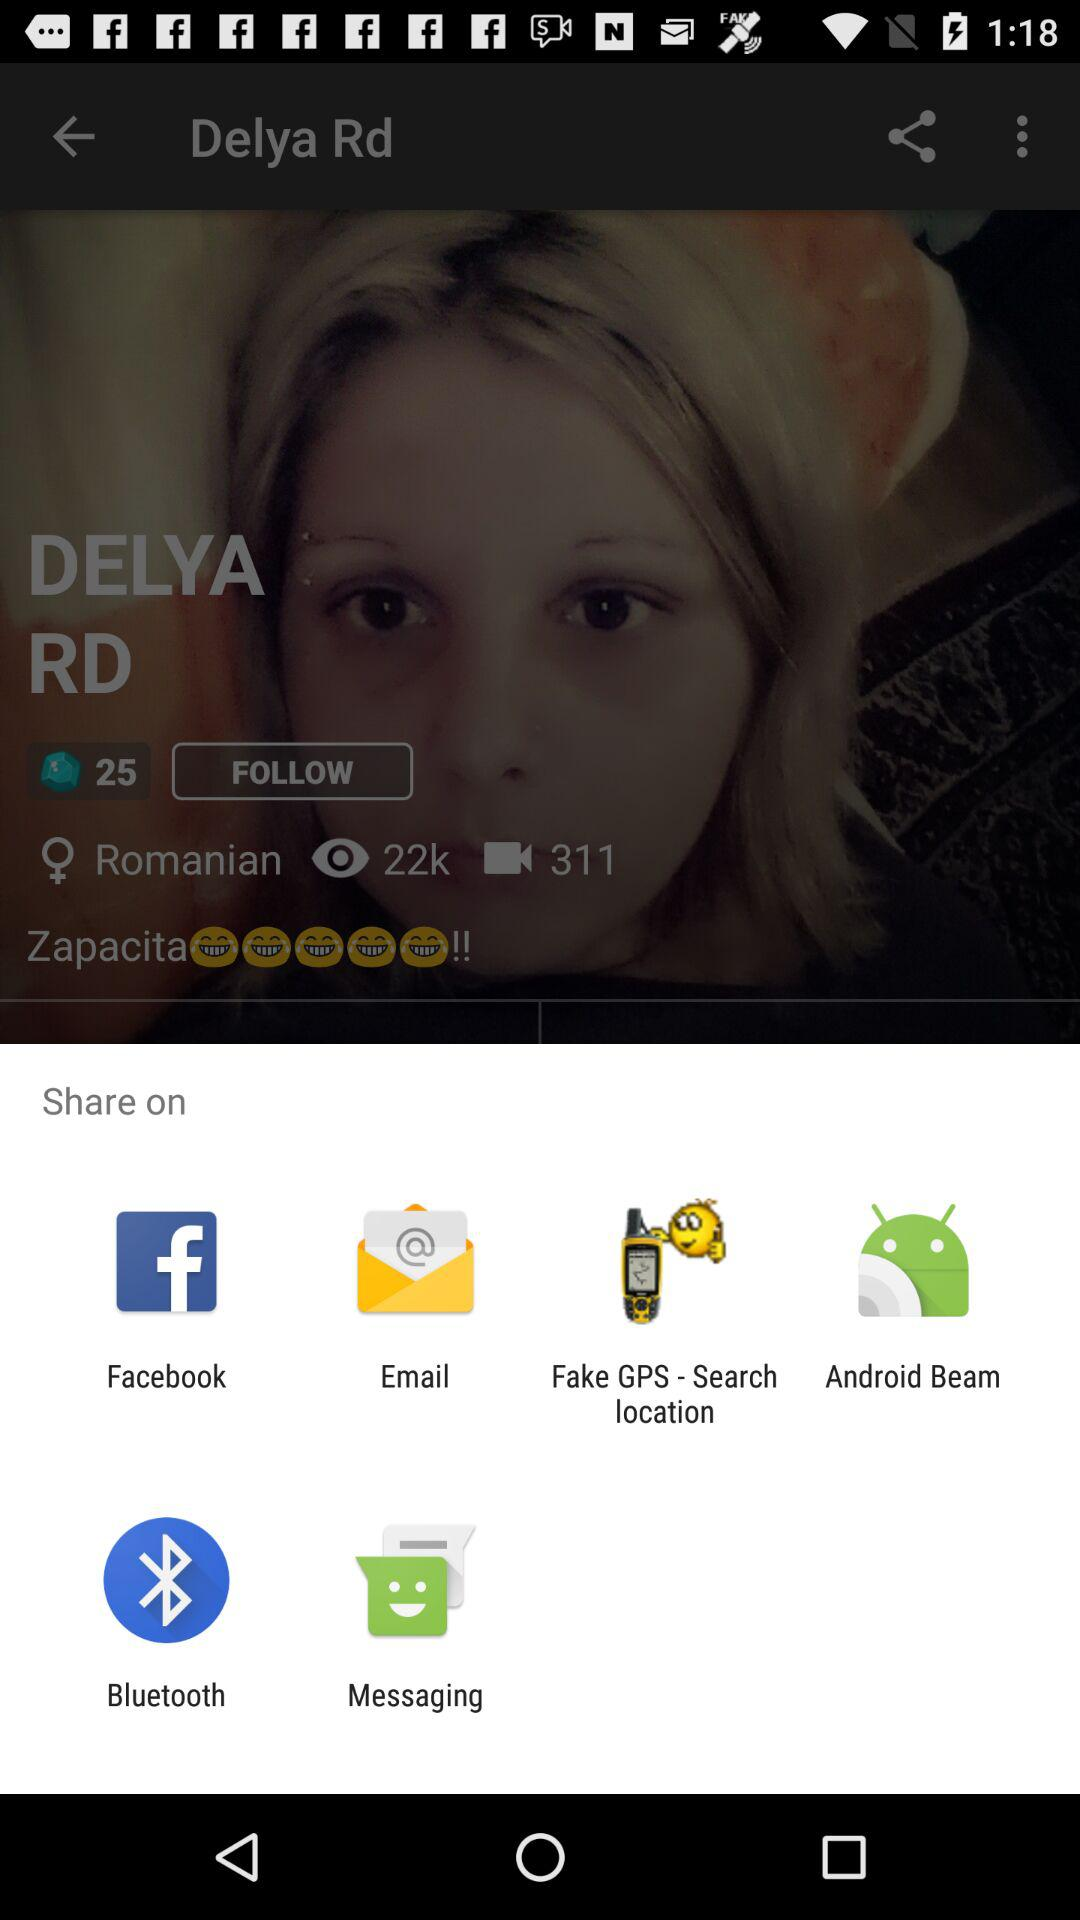From what app can we share? You can share with "Facebook", "Email", "Fake GPS - Search location", "Android Beam", "Bluetooth" and "Messaging". 